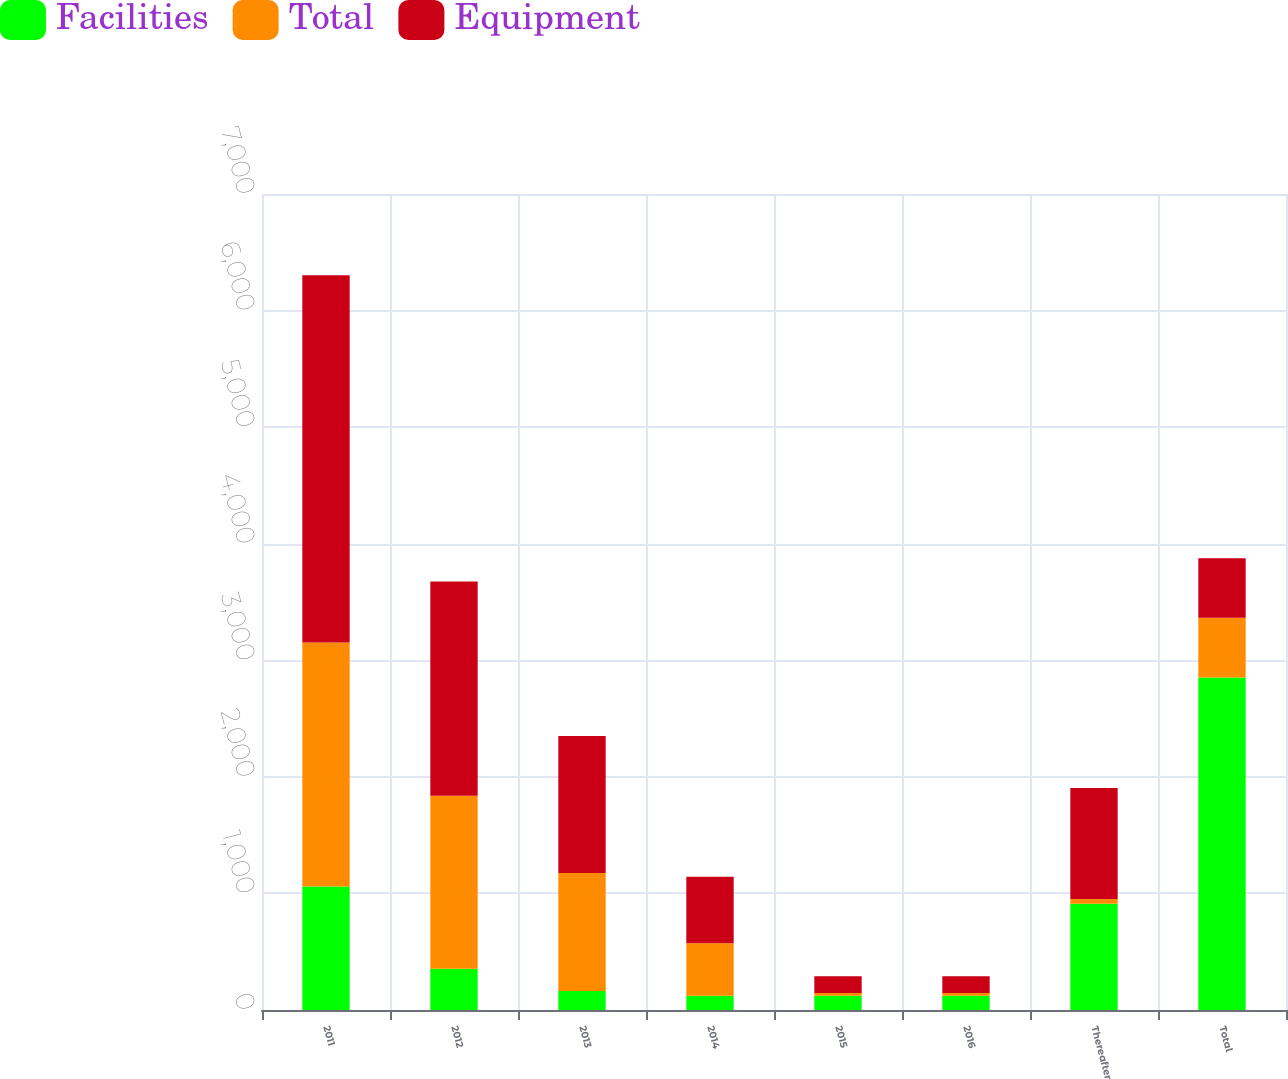Convert chart. <chart><loc_0><loc_0><loc_500><loc_500><stacked_bar_chart><ecel><fcel>2011<fcel>2012<fcel>2013<fcel>2014<fcel>2015<fcel>2016<fcel>Thereafter<fcel>Total<nl><fcel>Facilities<fcel>1060<fcel>354<fcel>162<fcel>122<fcel>122<fcel>122<fcel>911<fcel>2853<nl><fcel>Total<fcel>2092<fcel>1484<fcel>1013<fcel>450<fcel>23<fcel>23<fcel>41<fcel>511<nl><fcel>Equipment<fcel>3152<fcel>1838<fcel>1175<fcel>572<fcel>145<fcel>145<fcel>952<fcel>511<nl></chart> 